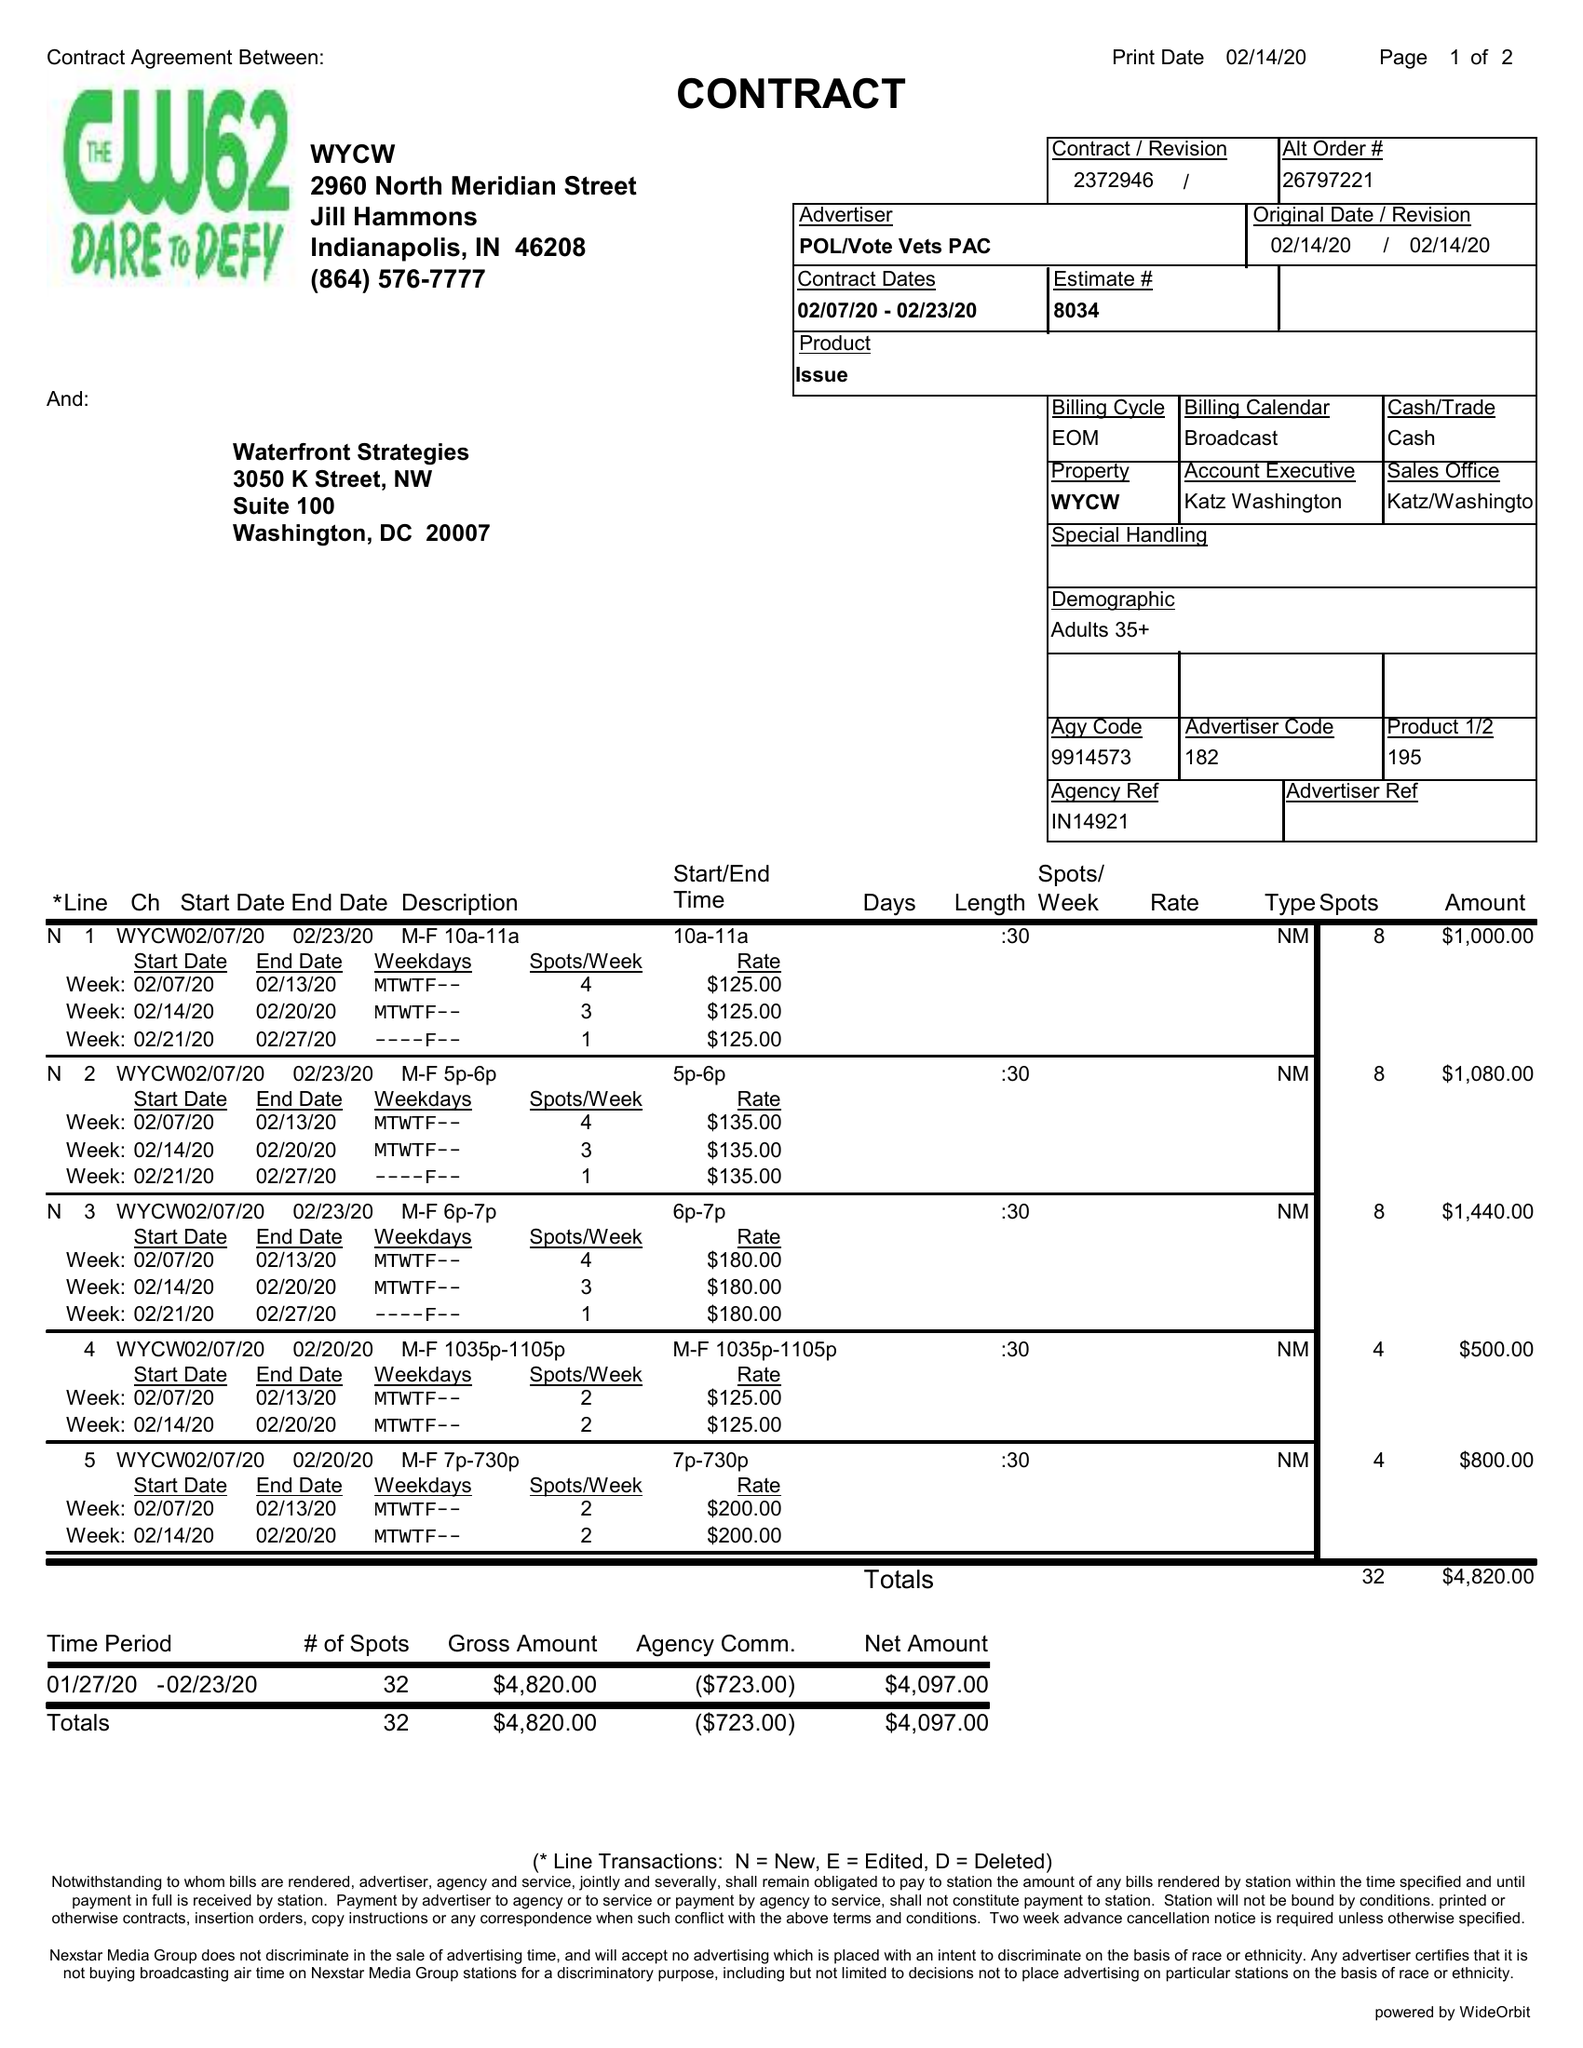What is the value for the advertiser?
Answer the question using a single word or phrase. POL/VOTEVETSPAC 